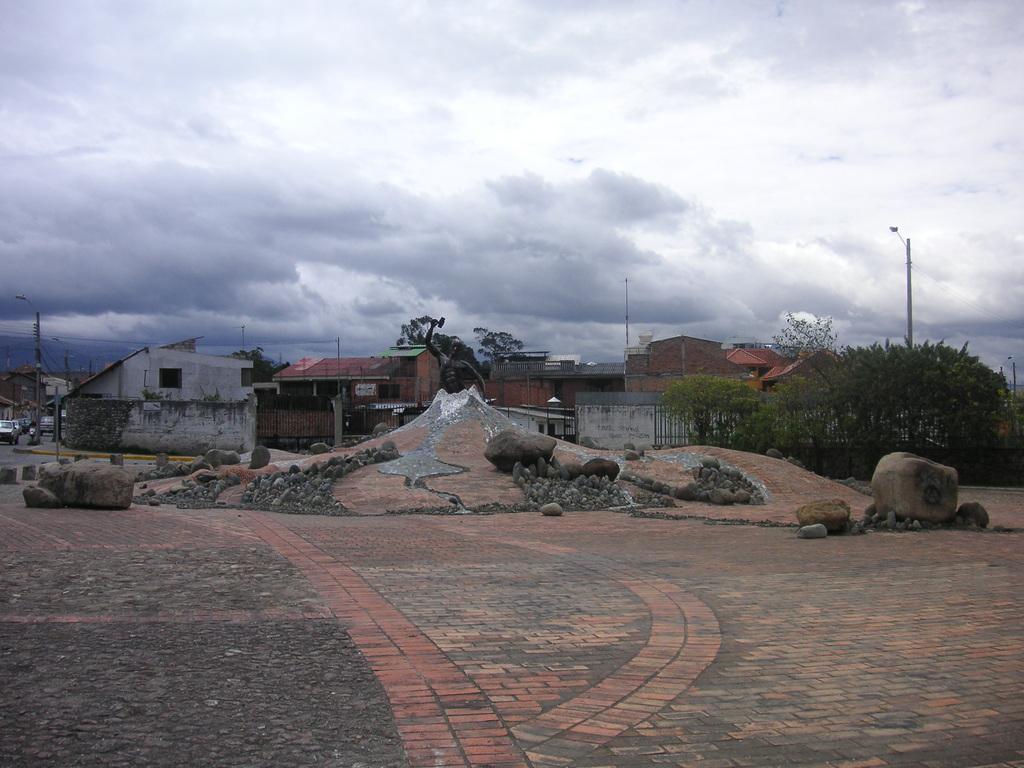Please provide a concise description of this image. In the image we can see there are many houses and stones. Here we can see footpath, trees, poles and a cloudy sky. 